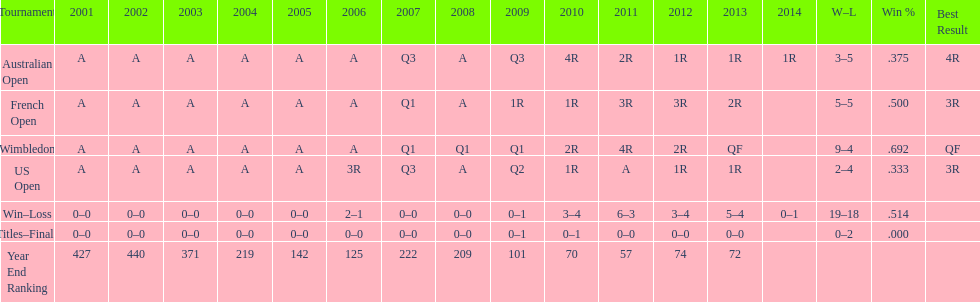Which years was a ranking below 200 achieved? 2005, 2006, 2009, 2010, 2011, 2012, 2013. 